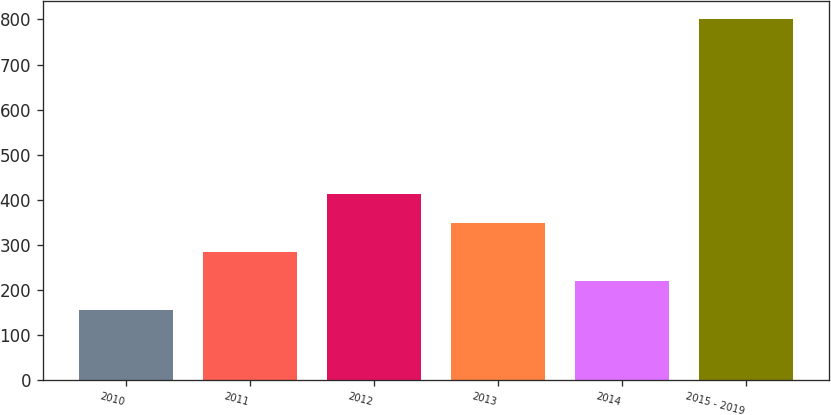<chart> <loc_0><loc_0><loc_500><loc_500><bar_chart><fcel>2010<fcel>2011<fcel>2012<fcel>2013<fcel>2014<fcel>2015 - 2019<nl><fcel>155<fcel>284.2<fcel>413.4<fcel>348.8<fcel>219.6<fcel>801<nl></chart> 